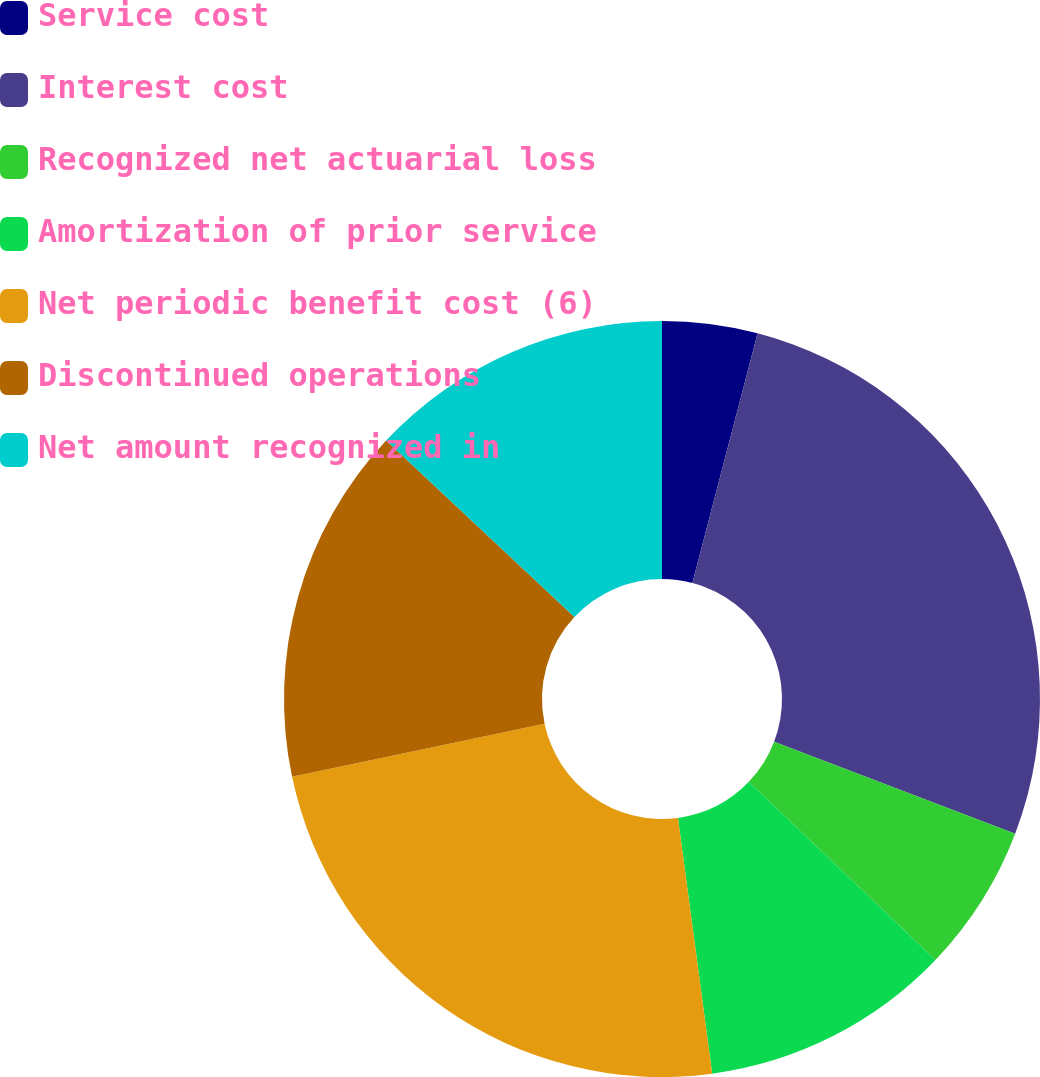Convert chart. <chart><loc_0><loc_0><loc_500><loc_500><pie_chart><fcel>Service cost<fcel>Interest cost<fcel>Recognized net actuarial loss<fcel>Amortization of prior service<fcel>Net periodic benefit cost (6)<fcel>Discontinued operations<fcel>Net amount recognized in<nl><fcel>4.07%<fcel>26.73%<fcel>6.33%<fcel>10.75%<fcel>23.82%<fcel>15.28%<fcel>13.02%<nl></chart> 